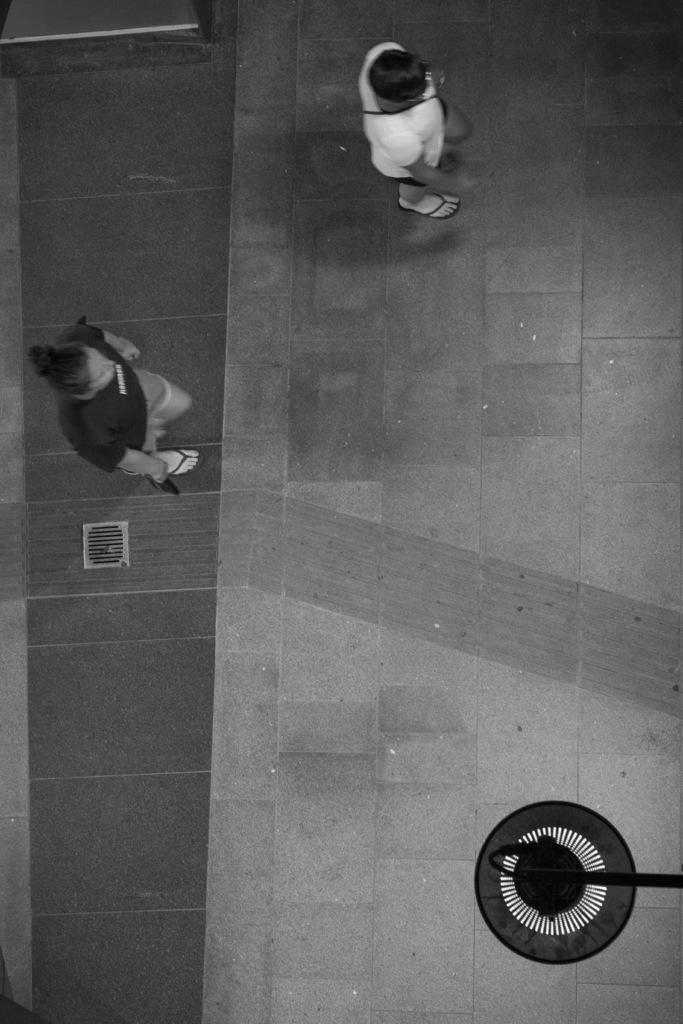Please provide a concise description of this image. In this image, we can see persons wearing clothes. There is an object in the bottom right of the image. 